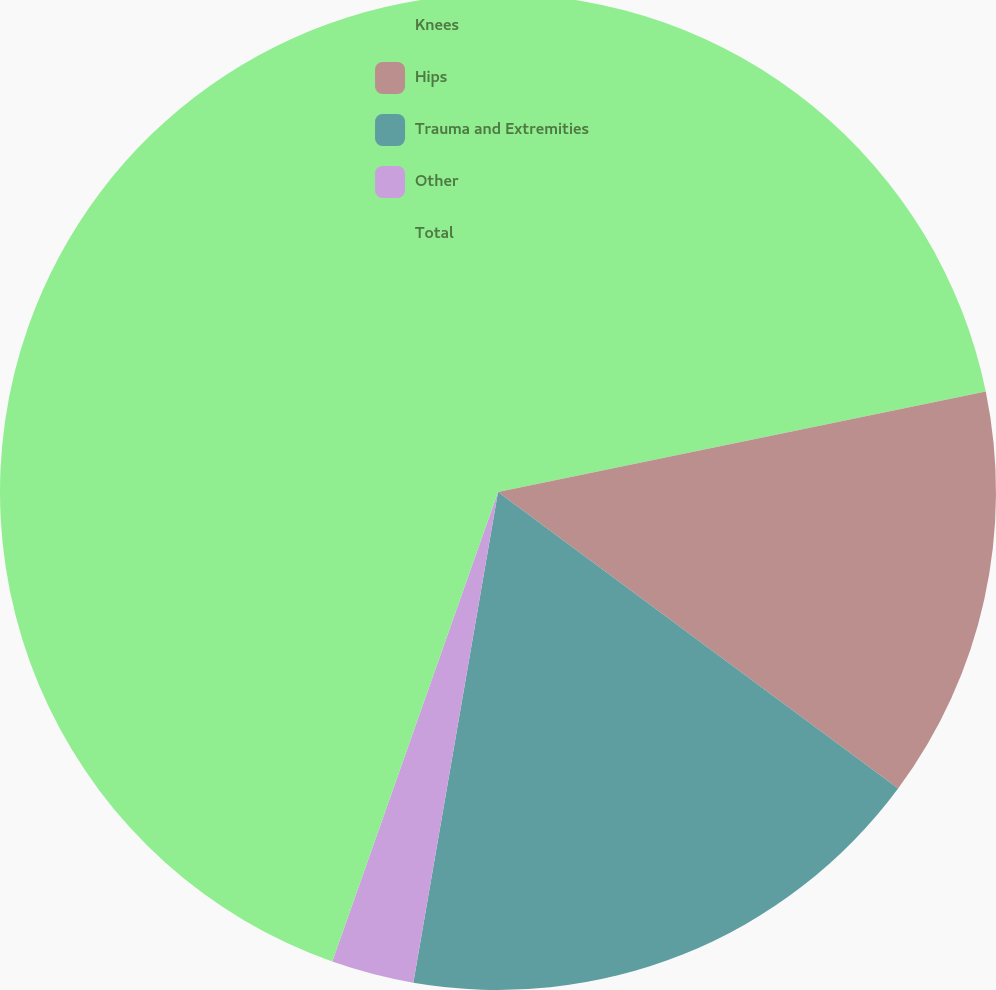Convert chart to OTSL. <chart><loc_0><loc_0><loc_500><loc_500><pie_chart><fcel>Knees<fcel>Hips<fcel>Trauma and Extremities<fcel>Other<fcel>Total<nl><fcel>21.77%<fcel>13.38%<fcel>17.57%<fcel>2.68%<fcel>44.6%<nl></chart> 